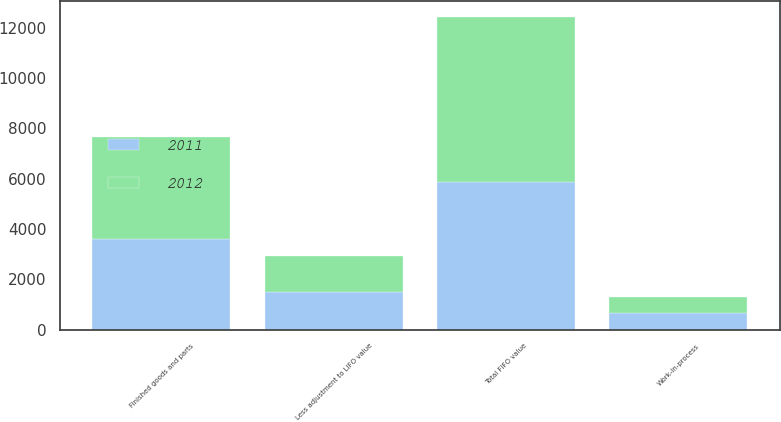Convert chart. <chart><loc_0><loc_0><loc_500><loc_500><stacked_bar_chart><ecel><fcel>Work-in-process<fcel>Finished goods and parts<fcel>Total FIFO value<fcel>Less adjustment to LIFO value<nl><fcel>2012<fcel>652<fcel>4065<fcel>6591<fcel>1421<nl><fcel>2011<fcel>647<fcel>3584<fcel>5857<fcel>1486<nl></chart> 